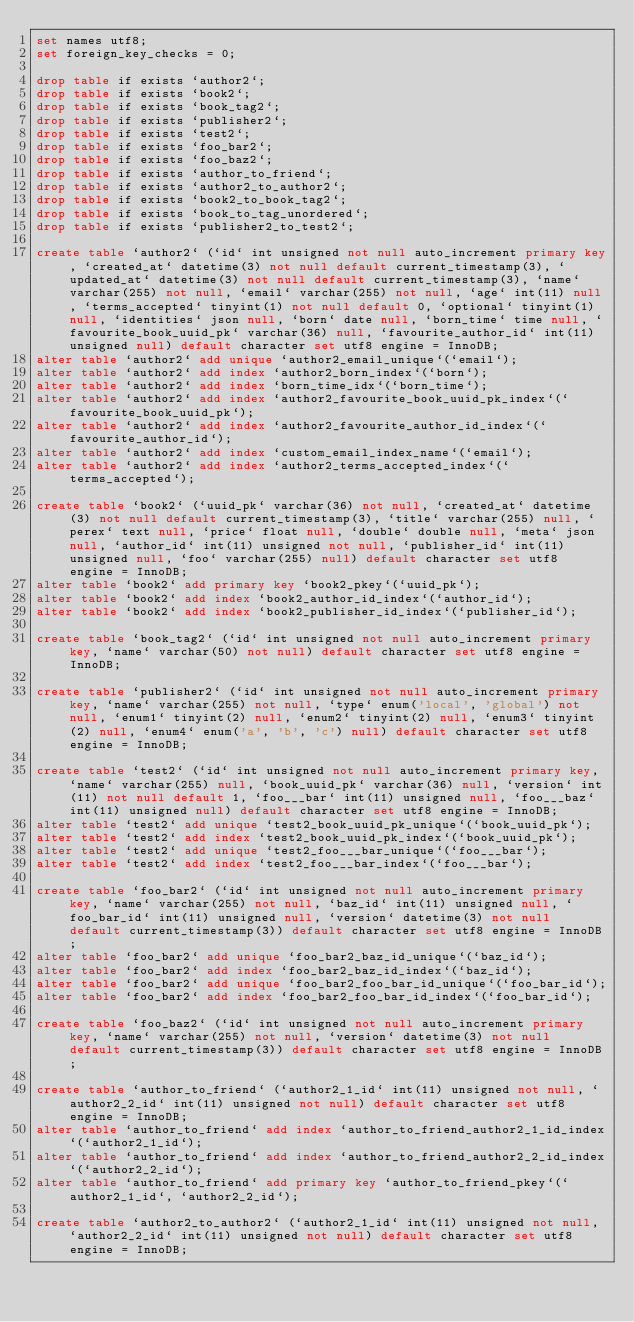Convert code to text. <code><loc_0><loc_0><loc_500><loc_500><_SQL_>set names utf8;
set foreign_key_checks = 0;

drop table if exists `author2`;
drop table if exists `book2`;
drop table if exists `book_tag2`;
drop table if exists `publisher2`;
drop table if exists `test2`;
drop table if exists `foo_bar2`;
drop table if exists `foo_baz2`;
drop table if exists `author_to_friend`;
drop table if exists `author2_to_author2`;
drop table if exists `book2_to_book_tag2`;
drop table if exists `book_to_tag_unordered`;
drop table if exists `publisher2_to_test2`;

create table `author2` (`id` int unsigned not null auto_increment primary key, `created_at` datetime(3) not null default current_timestamp(3), `updated_at` datetime(3) not null default current_timestamp(3), `name` varchar(255) not null, `email` varchar(255) not null, `age` int(11) null, `terms_accepted` tinyint(1) not null default 0, `optional` tinyint(1) null, `identities` json null, `born` date null, `born_time` time null, `favourite_book_uuid_pk` varchar(36) null, `favourite_author_id` int(11) unsigned null) default character set utf8 engine = InnoDB;
alter table `author2` add unique `author2_email_unique`(`email`);
alter table `author2` add index `author2_born_index`(`born`);
alter table `author2` add index `born_time_idx`(`born_time`);
alter table `author2` add index `author2_favourite_book_uuid_pk_index`(`favourite_book_uuid_pk`);
alter table `author2` add index `author2_favourite_author_id_index`(`favourite_author_id`);
alter table `author2` add index `custom_email_index_name`(`email`);
alter table `author2` add index `author2_terms_accepted_index`(`terms_accepted`);

create table `book2` (`uuid_pk` varchar(36) not null, `created_at` datetime(3) not null default current_timestamp(3), `title` varchar(255) null, `perex` text null, `price` float null, `double` double null, `meta` json null, `author_id` int(11) unsigned not null, `publisher_id` int(11) unsigned null, `foo` varchar(255) null) default character set utf8 engine = InnoDB;
alter table `book2` add primary key `book2_pkey`(`uuid_pk`);
alter table `book2` add index `book2_author_id_index`(`author_id`);
alter table `book2` add index `book2_publisher_id_index`(`publisher_id`);

create table `book_tag2` (`id` int unsigned not null auto_increment primary key, `name` varchar(50) not null) default character set utf8 engine = InnoDB;

create table `publisher2` (`id` int unsigned not null auto_increment primary key, `name` varchar(255) not null, `type` enum('local', 'global') not null, `enum1` tinyint(2) null, `enum2` tinyint(2) null, `enum3` tinyint(2) null, `enum4` enum('a', 'b', 'c') null) default character set utf8 engine = InnoDB;

create table `test2` (`id` int unsigned not null auto_increment primary key, `name` varchar(255) null, `book_uuid_pk` varchar(36) null, `version` int(11) not null default 1, `foo___bar` int(11) unsigned null, `foo___baz` int(11) unsigned null) default character set utf8 engine = InnoDB;
alter table `test2` add unique `test2_book_uuid_pk_unique`(`book_uuid_pk`);
alter table `test2` add index `test2_book_uuid_pk_index`(`book_uuid_pk`);
alter table `test2` add unique `test2_foo___bar_unique`(`foo___bar`);
alter table `test2` add index `test2_foo___bar_index`(`foo___bar`);

create table `foo_bar2` (`id` int unsigned not null auto_increment primary key, `name` varchar(255) not null, `baz_id` int(11) unsigned null, `foo_bar_id` int(11) unsigned null, `version` datetime(3) not null default current_timestamp(3)) default character set utf8 engine = InnoDB;
alter table `foo_bar2` add unique `foo_bar2_baz_id_unique`(`baz_id`);
alter table `foo_bar2` add index `foo_bar2_baz_id_index`(`baz_id`);
alter table `foo_bar2` add unique `foo_bar2_foo_bar_id_unique`(`foo_bar_id`);
alter table `foo_bar2` add index `foo_bar2_foo_bar_id_index`(`foo_bar_id`);

create table `foo_baz2` (`id` int unsigned not null auto_increment primary key, `name` varchar(255) not null, `version` datetime(3) not null default current_timestamp(3)) default character set utf8 engine = InnoDB;

create table `author_to_friend` (`author2_1_id` int(11) unsigned not null, `author2_2_id` int(11) unsigned not null) default character set utf8 engine = InnoDB;
alter table `author_to_friend` add index `author_to_friend_author2_1_id_index`(`author2_1_id`);
alter table `author_to_friend` add index `author_to_friend_author2_2_id_index`(`author2_2_id`);
alter table `author_to_friend` add primary key `author_to_friend_pkey`(`author2_1_id`, `author2_2_id`);

create table `author2_to_author2` (`author2_1_id` int(11) unsigned not null, `author2_2_id` int(11) unsigned not null) default character set utf8 engine = InnoDB;</code> 